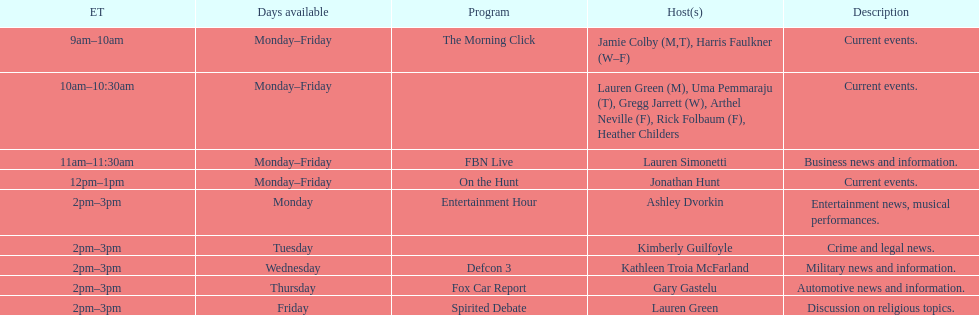Tell me the number of shows that only have one host per day. 7. 